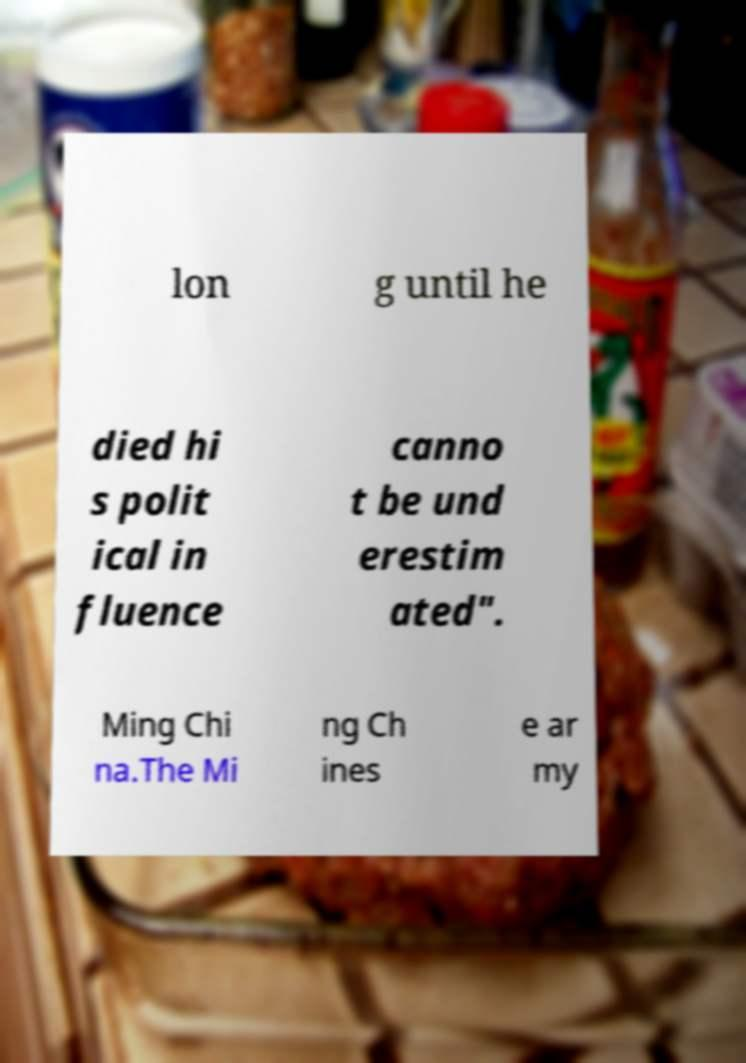For documentation purposes, I need the text within this image transcribed. Could you provide that? lon g until he died hi s polit ical in fluence canno t be und erestim ated". Ming Chi na.The Mi ng Ch ines e ar my 